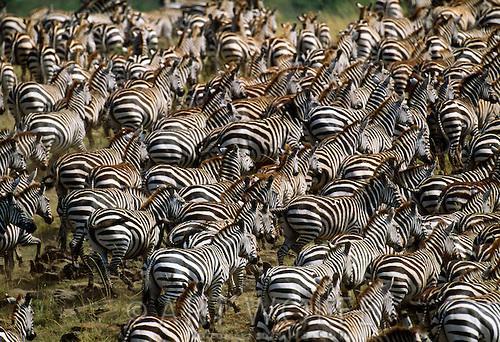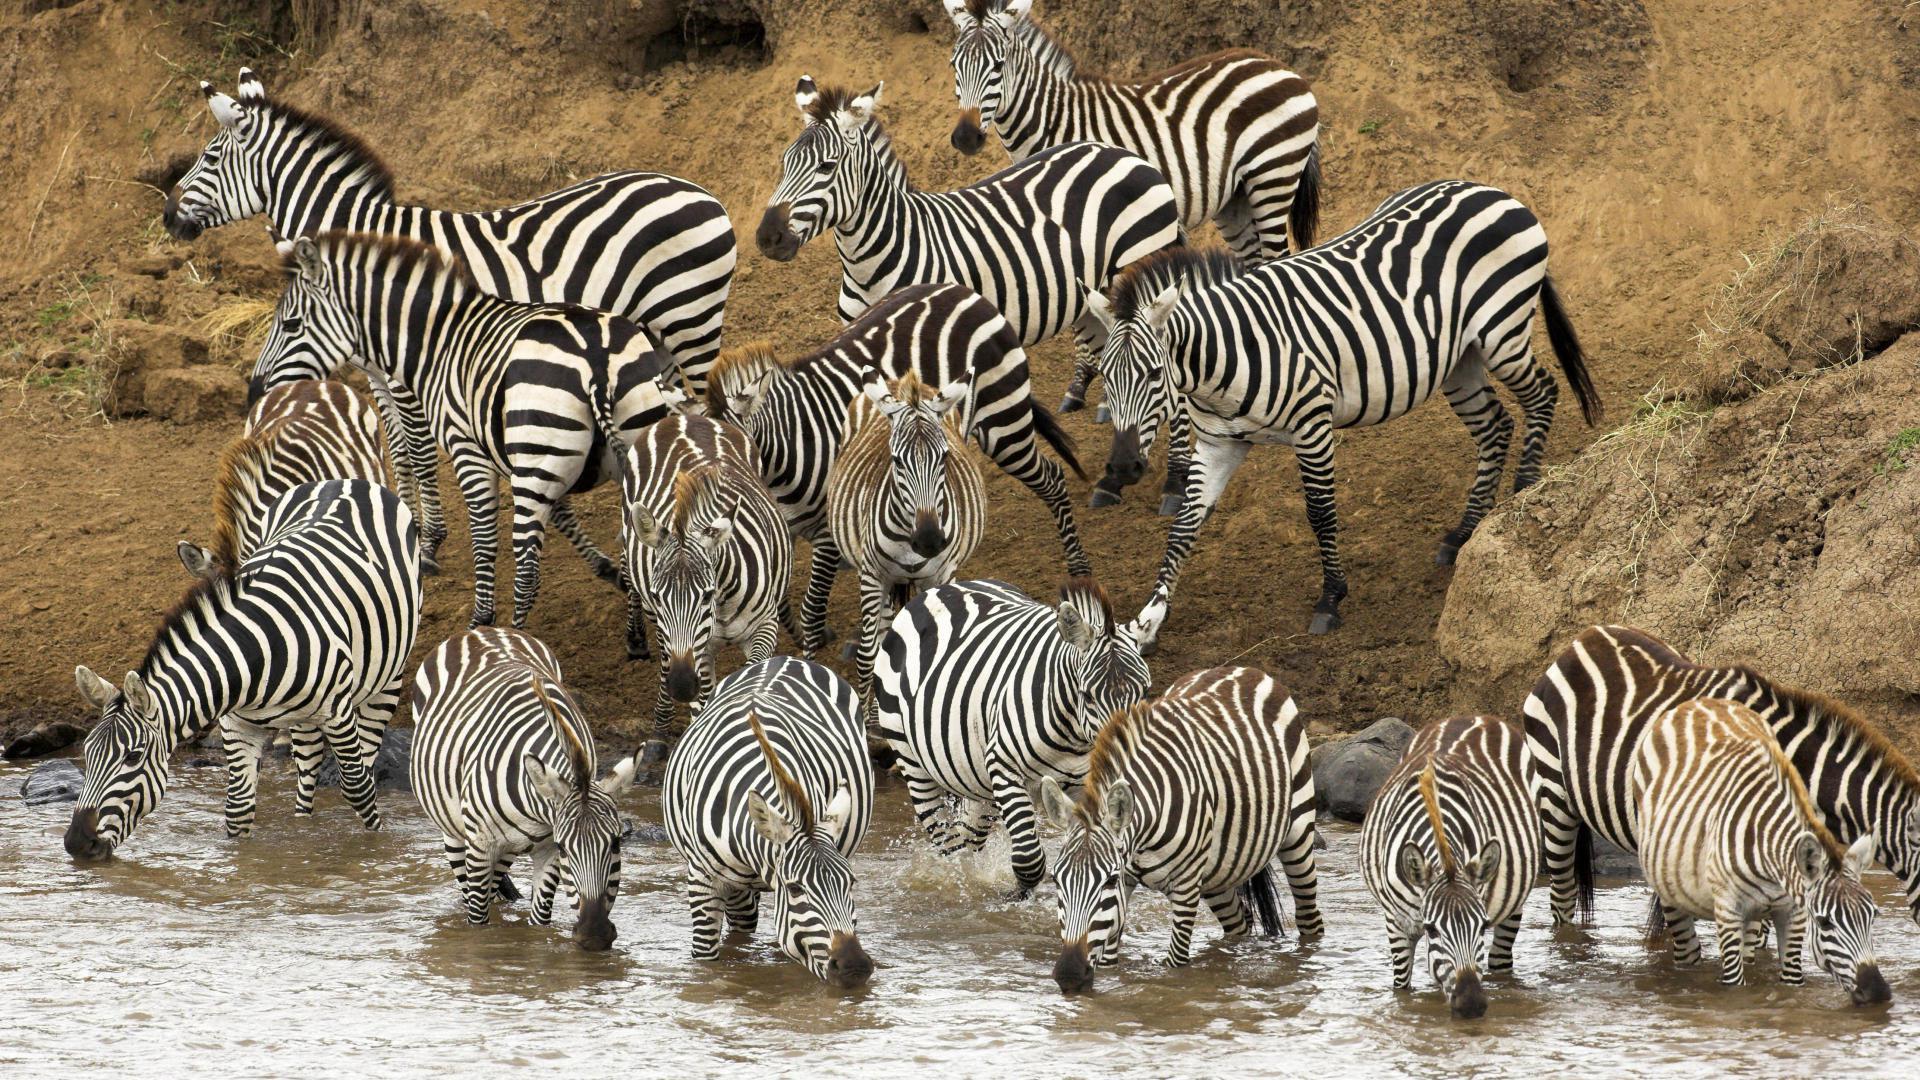The first image is the image on the left, the second image is the image on the right. Assess this claim about the two images: "In the right image, there are zebras drinking from water.". Correct or not? Answer yes or no. Yes. The first image is the image on the left, the second image is the image on the right. Assess this claim about the two images: "In one of the images, some of the zebras are in the water, and in the other image, none of the zebras are in the water.". Correct or not? Answer yes or no. Yes. 